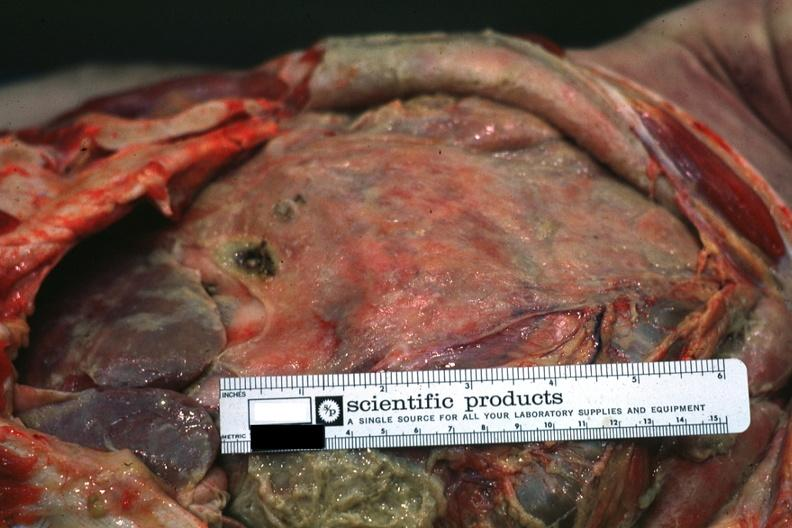does carcinomatosis endometrium primary show intestines covered by fibrinopurulent membrane due to ruptured peptic ulcer?
Answer the question using a single word or phrase. No 